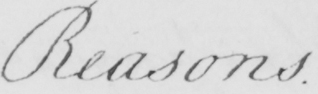What is written in this line of handwriting? Reasons 